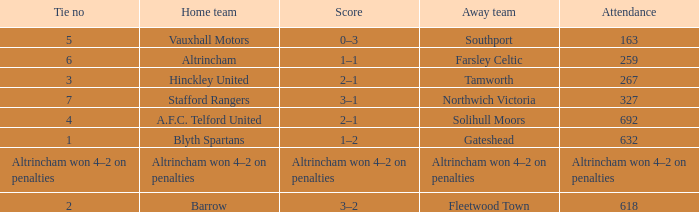What was the attendance for the away team Solihull Moors? 692.0. 